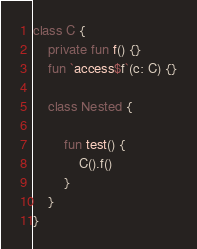Convert code to text. <code><loc_0><loc_0><loc_500><loc_500><_Kotlin_>class C {
    private fun f() {}
    fun `access$f`(c: C) {}

    class Nested {

        fun test() {
            C().f()
        }
    }
}
</code> 